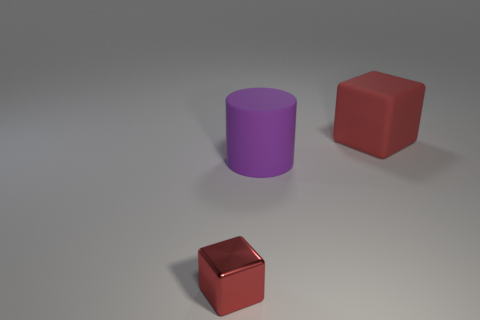Add 3 large things. How many objects exist? 6 Subtract all blocks. How many objects are left? 1 Subtract all big gray spheres. Subtract all big red cubes. How many objects are left? 2 Add 1 large matte cubes. How many large matte cubes are left? 2 Add 3 small red metal cubes. How many small red metal cubes exist? 4 Subtract 0 gray cylinders. How many objects are left? 3 